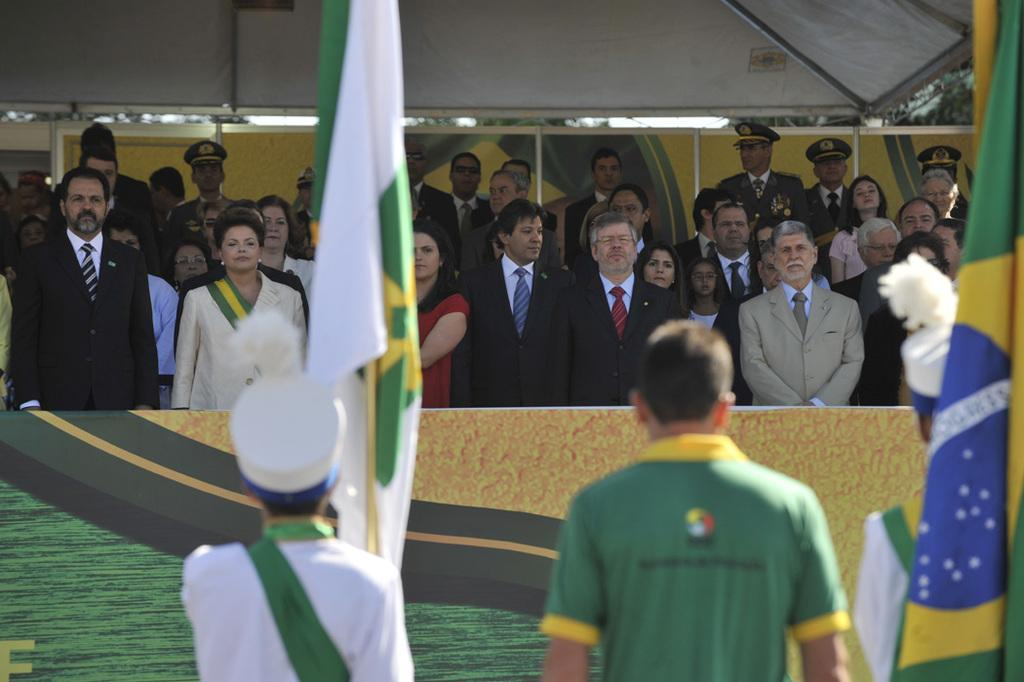What can be seen in the image? There are people standing in the image. What else is present in the image besides people? There are flags and a banner in the image. Can you describe the location of the banner? The banner is in the background of the image. What else can be seen in the background of the image? There are people standing under a tent in the background of the image. What type of soap is being used to clean the flags in the image? There is no soap present in the image, and the flags do not appear to be cleaned. 